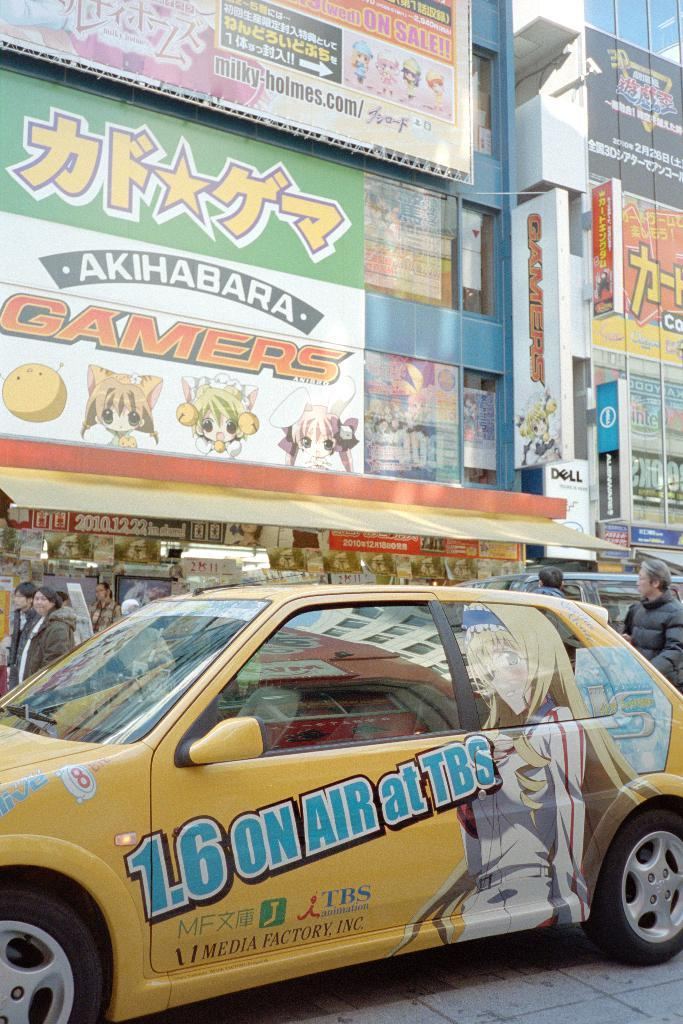<image>
Offer a succinct explanation of the picture presented. A city with sign up on buildings is shown with a car that has 1.6 ON AIR at TBS 